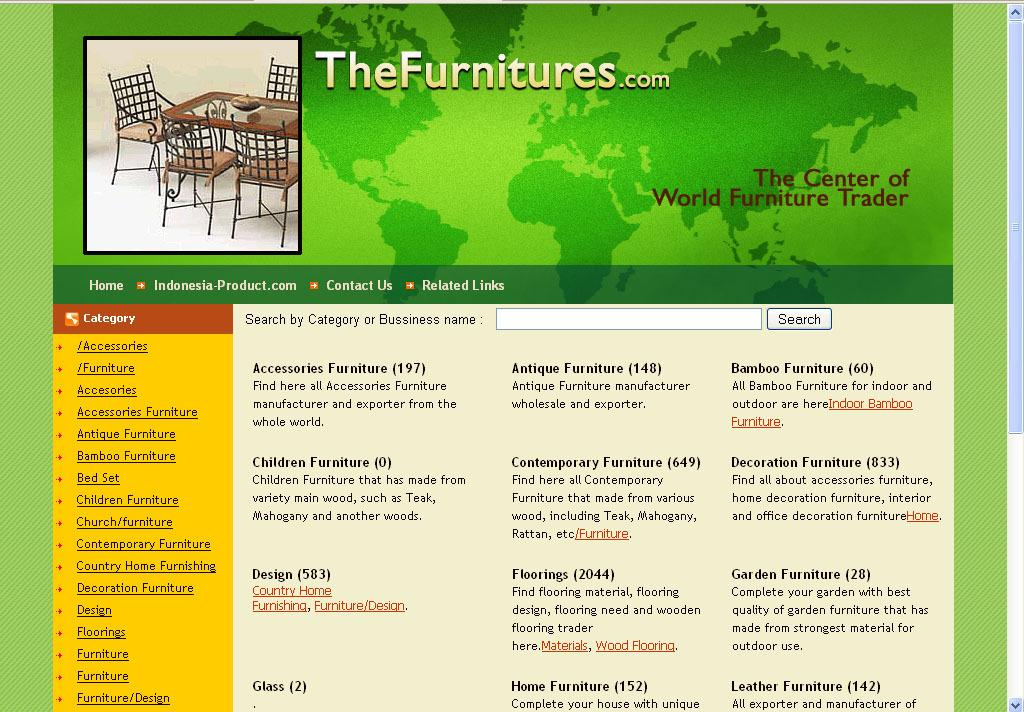What type of content is displayed in the image? The image is a web page. What can be seen in the picture on the web page? There is a picture of a table and chairs on the web page. What other elements are present on the web page besides the picture? There is text present on the web page. How many police officers are visible in the image? There are no police officers present in the image, as it is a web page featuring a picture of a table and chairs. What type of coat is being worn by the person in the image? There is no person wearing a coat in the image, as it features a table and chairs. 